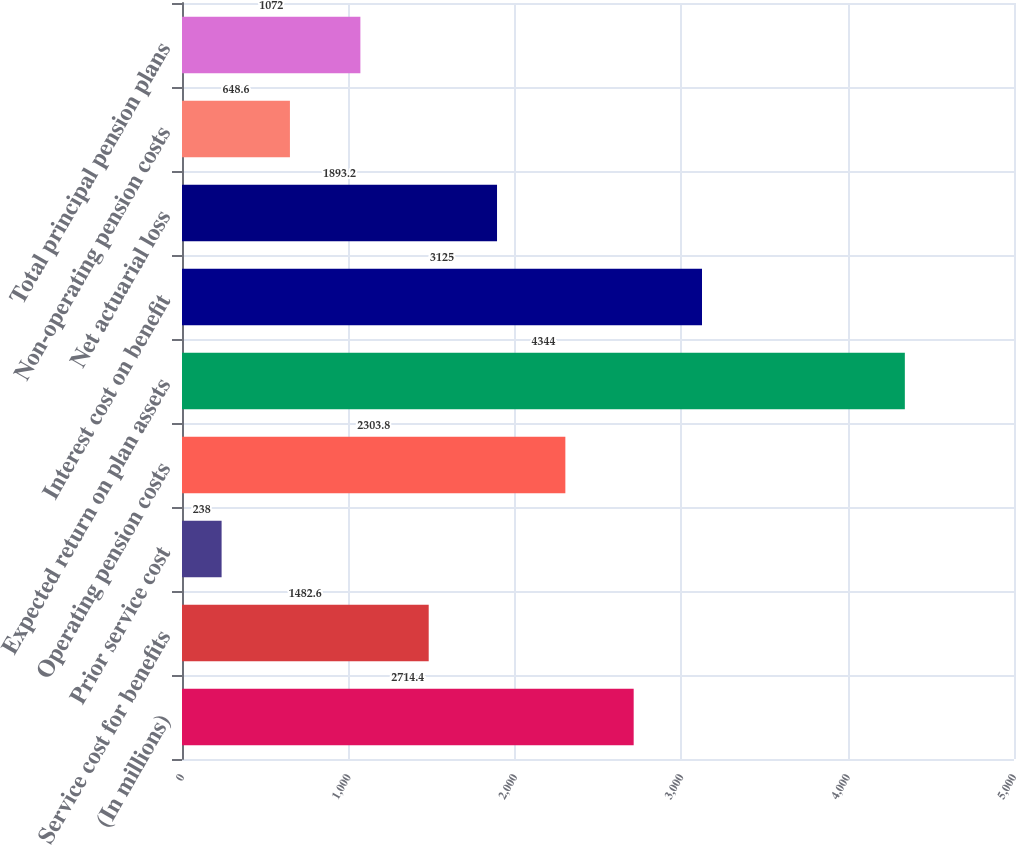<chart> <loc_0><loc_0><loc_500><loc_500><bar_chart><fcel>(In millions)<fcel>Service cost for benefits<fcel>Prior service cost<fcel>Operating pension costs<fcel>Expected return on plan assets<fcel>Interest cost on benefit<fcel>Net actuarial loss<fcel>Non-operating pension costs<fcel>Total principal pension plans<nl><fcel>2714.4<fcel>1482.6<fcel>238<fcel>2303.8<fcel>4344<fcel>3125<fcel>1893.2<fcel>648.6<fcel>1072<nl></chart> 